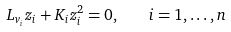<formula> <loc_0><loc_0><loc_500><loc_500>L _ { v _ { i } } z _ { i } + K _ { i } z _ { i } ^ { 2 } = 0 , \quad i = 1 , \dots , n</formula> 